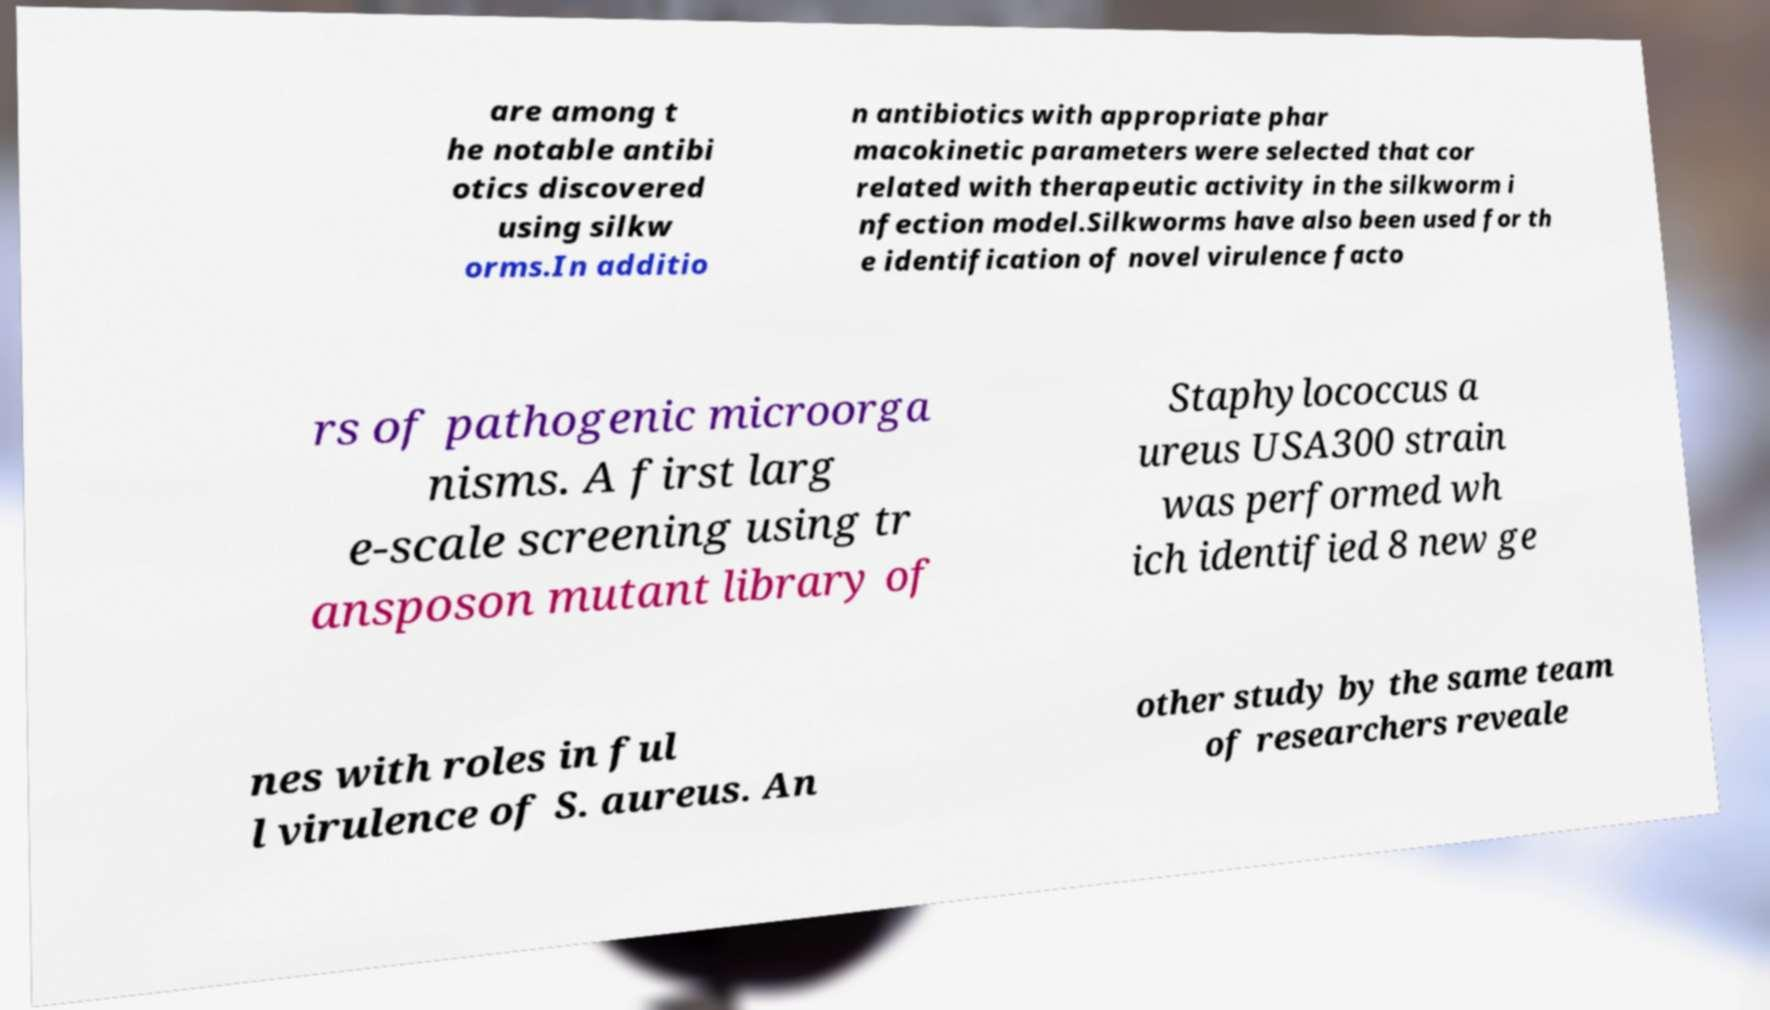Can you accurately transcribe the text from the provided image for me? are among t he notable antibi otics discovered using silkw orms.In additio n antibiotics with appropriate phar macokinetic parameters were selected that cor related with therapeutic activity in the silkworm i nfection model.Silkworms have also been used for th e identification of novel virulence facto rs of pathogenic microorga nisms. A first larg e-scale screening using tr ansposon mutant library of Staphylococcus a ureus USA300 strain was performed wh ich identified 8 new ge nes with roles in ful l virulence of S. aureus. An other study by the same team of researchers reveale 